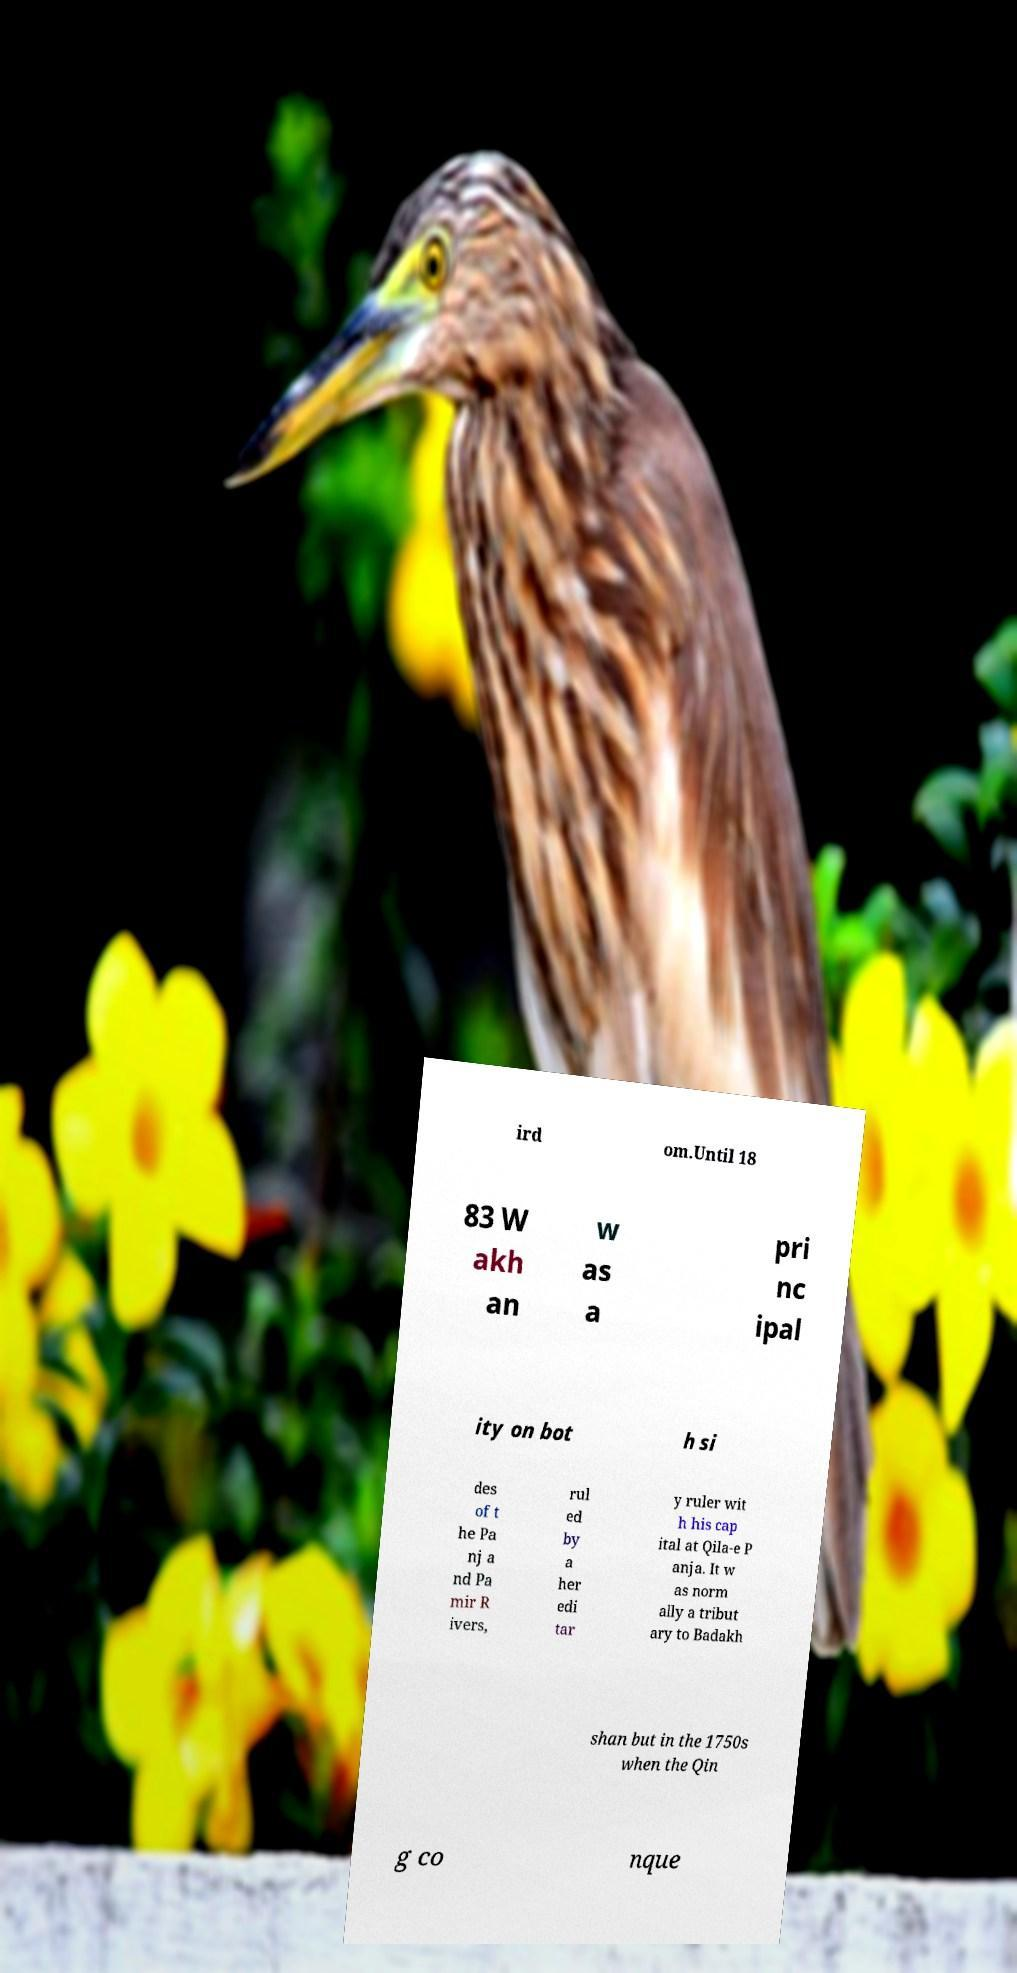I need the written content from this picture converted into text. Can you do that? ird om.Until 18 83 W akh an w as a pri nc ipal ity on bot h si des of t he Pa nj a nd Pa mir R ivers, rul ed by a her edi tar y ruler wit h his cap ital at Qila-e P anja. It w as norm ally a tribut ary to Badakh shan but in the 1750s when the Qin g co nque 